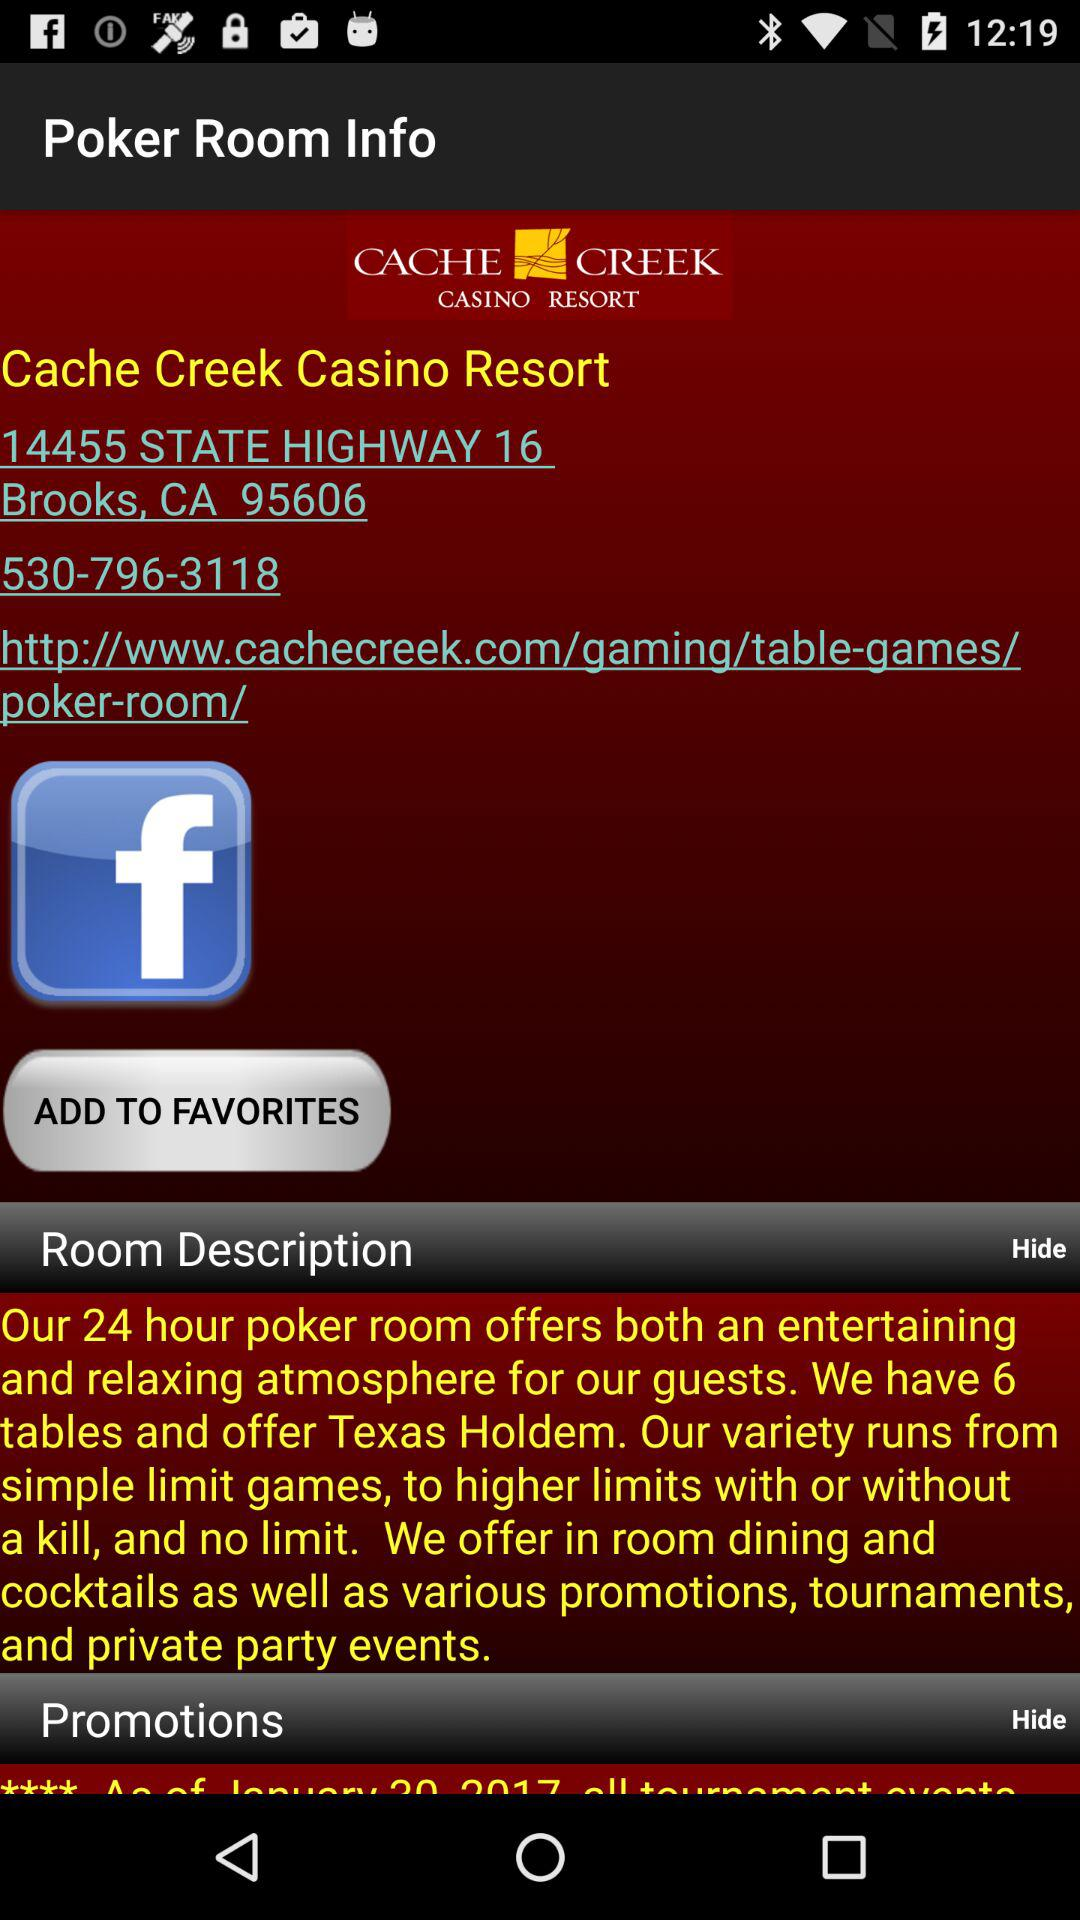What is the website of "Cache Creek Casino Resort"? The website of "Cache Creek Casino Resort" is www.cachecreek.com. 